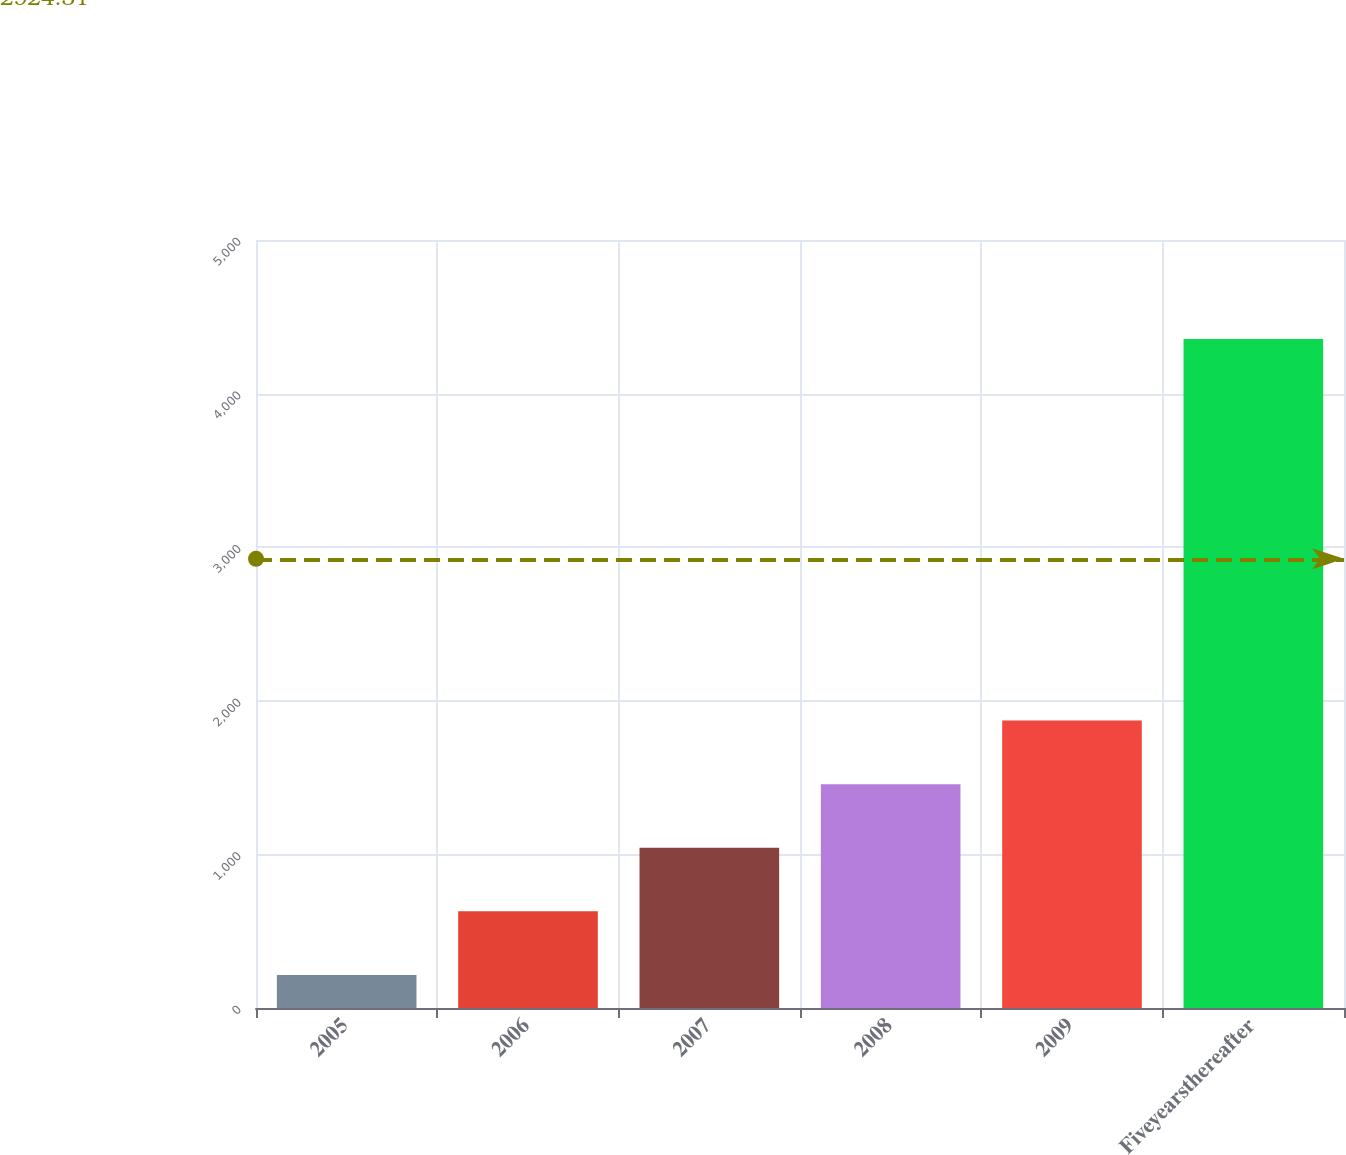<chart> <loc_0><loc_0><loc_500><loc_500><bar_chart><fcel>2005<fcel>2006<fcel>2007<fcel>2008<fcel>2009<fcel>Fiveyearsthereafter<nl><fcel>215<fcel>629.1<fcel>1043.2<fcel>1457.3<fcel>1871.4<fcel>4356<nl></chart> 